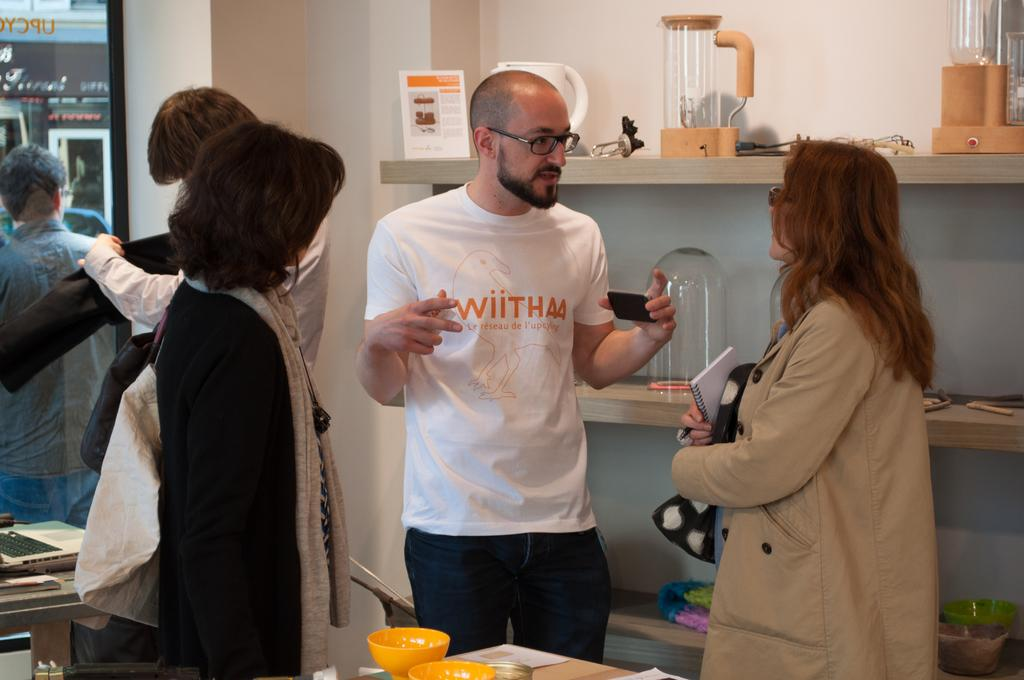What is happening in the image involving people? There are people standing in the image. What electronic device can be seen in the image? There is an electronic device in the image. What is on the table in the image? There are bowls on a table in the image. What type of architectural feature is present in the image? There is a glass window in the image. What is on the rack in the image? There are objects on a rack in the image. Can you tell me how many cats are fighting in the image? There are no cats or fighting depicted in the image. 